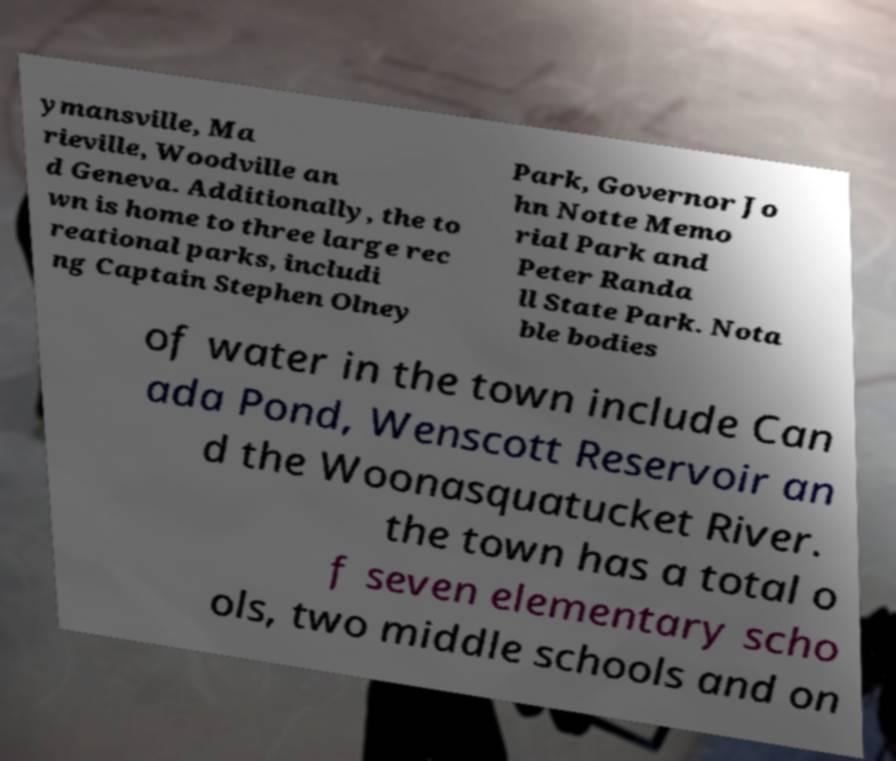Please identify and transcribe the text found in this image. ymansville, Ma rieville, Woodville an d Geneva. Additionally, the to wn is home to three large rec reational parks, includi ng Captain Stephen Olney Park, Governor Jo hn Notte Memo rial Park and Peter Randa ll State Park. Nota ble bodies of water in the town include Can ada Pond, Wenscott Reservoir an d the Woonasquatucket River. the town has a total o f seven elementary scho ols, two middle schools and on 